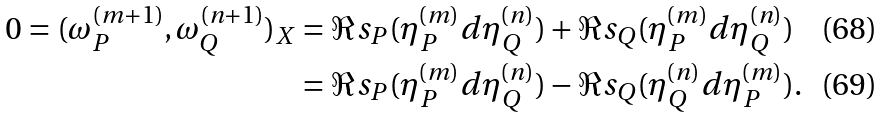Convert formula to latex. <formula><loc_0><loc_0><loc_500><loc_500>0 = ( \omega _ { P } ^ { ( m + 1 ) } , \omega _ { Q } ^ { ( n + 1 ) } ) _ { X } & = \Re s _ { P } ( \eta _ { P } ^ { ( m ) } d \eta _ { Q } ^ { ( n ) } ) + \Re s _ { Q } ( \eta _ { P } ^ { ( m ) } d \eta _ { Q } ^ { ( n ) } ) \\ & = \Re s _ { P } ( \eta _ { P } ^ { ( m ) } d \eta _ { Q } ^ { ( n ) } ) - \Re s _ { Q } ( \eta _ { Q } ^ { ( n ) } d \eta _ { P } ^ { ( m ) } ) .</formula> 